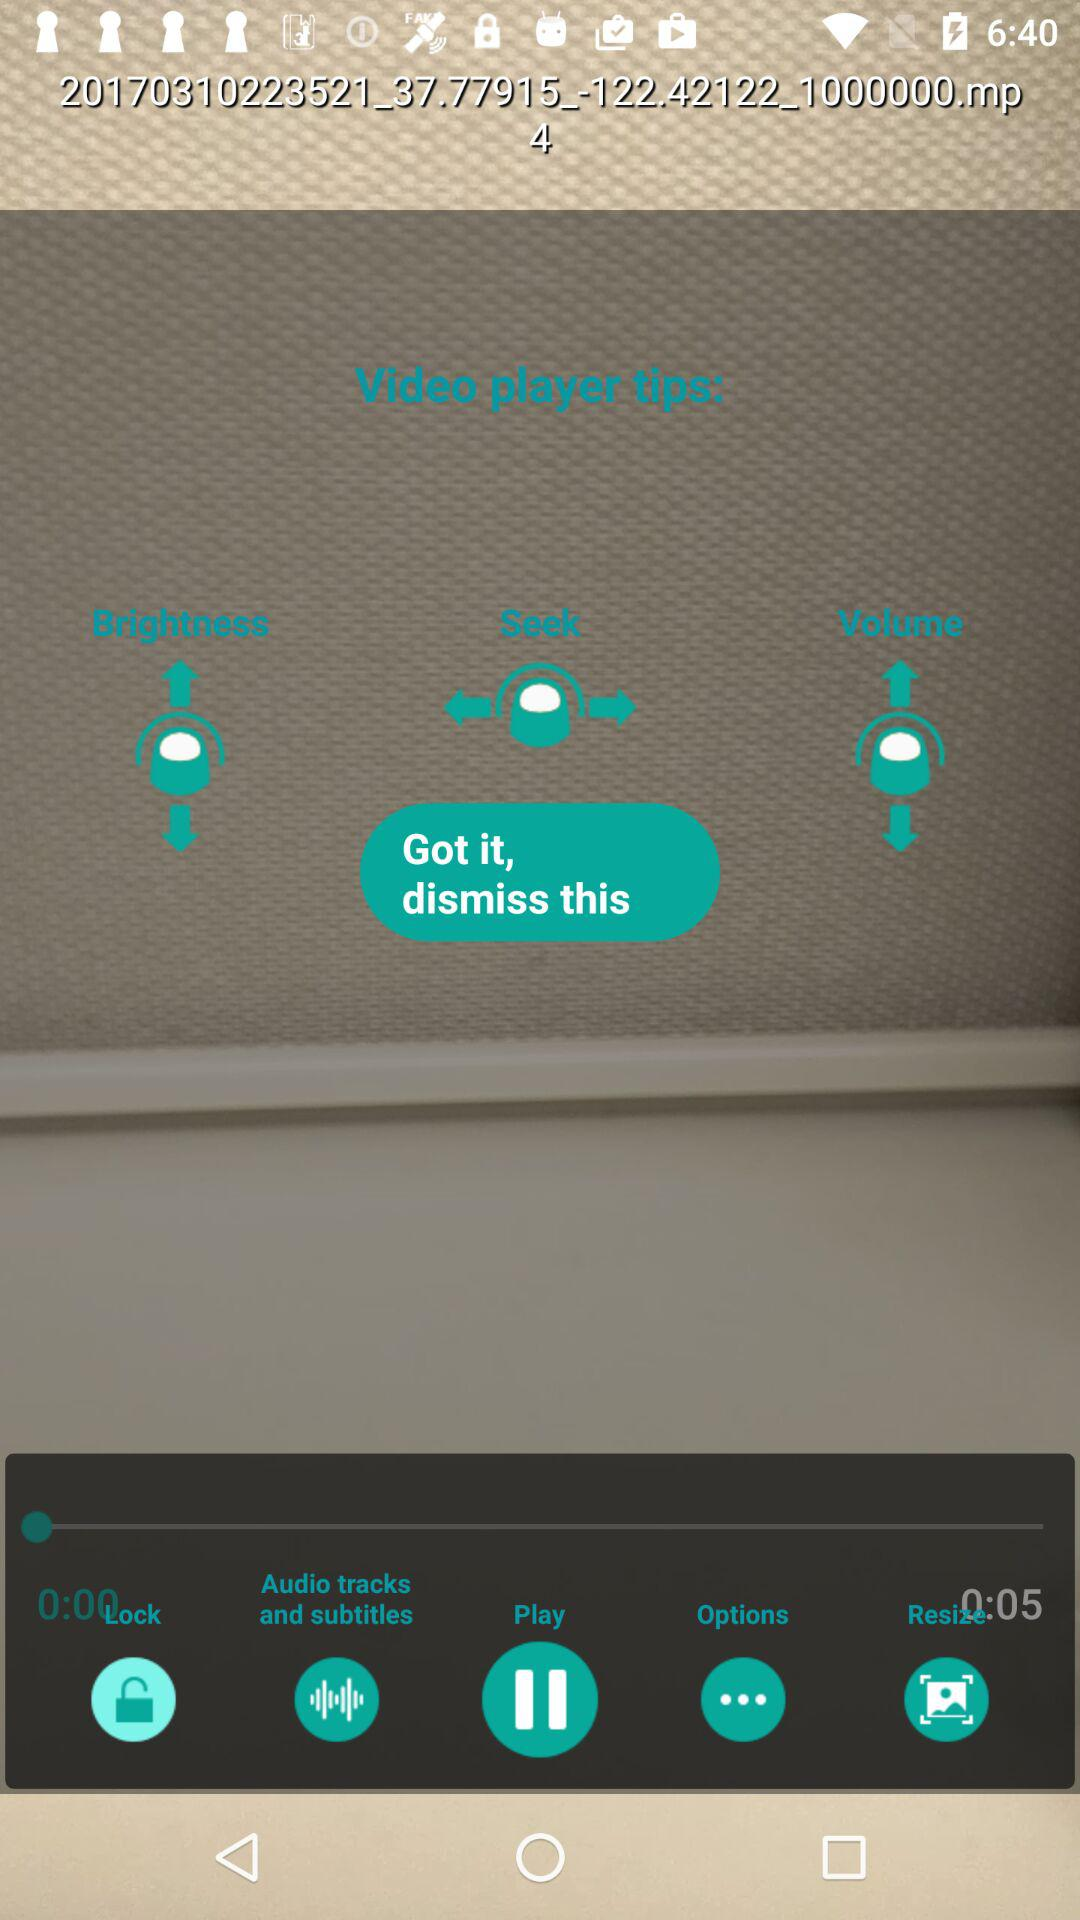What is the duration of the video? The duration of the video is 5 seconds. 